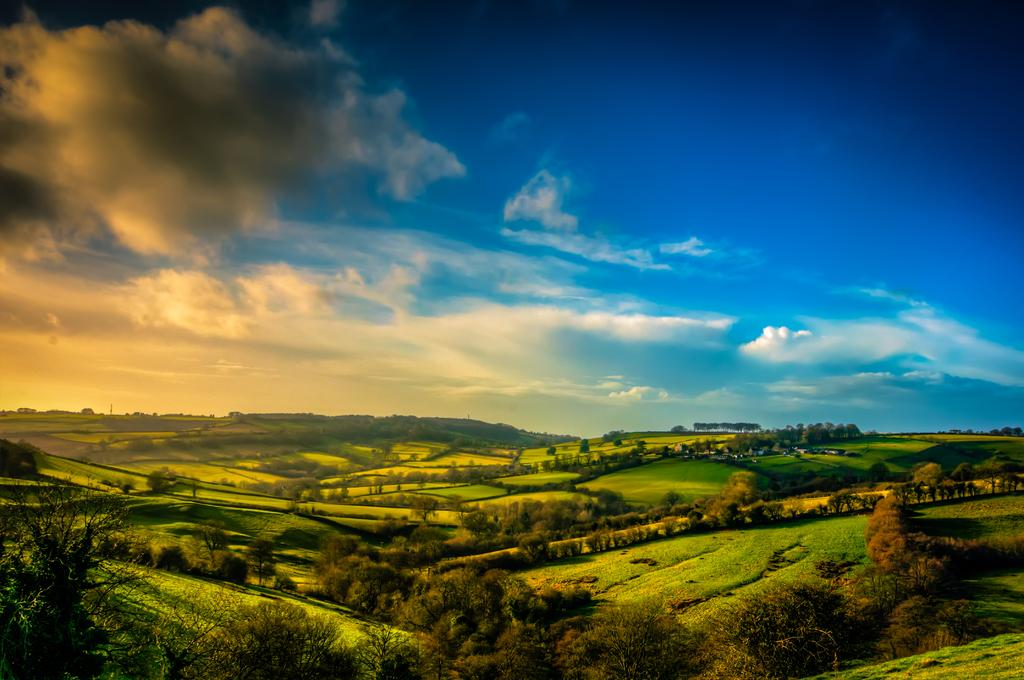What type of vegetation can be seen in the image? There are trees in the image. What geographical feature is present in the image? There is a valley in the image. What type of ground cover is visible in the image? There is grass in the image. What is visible at the top of the image? The sky is visible at the top of the image. What can be seen in the sky in the image? Clouds are present in the sky. What color is the ink in the image? There is no ink present in the image. What hobbies are being practiced in the image? There is no indication of any hobbies being practiced in the image. 